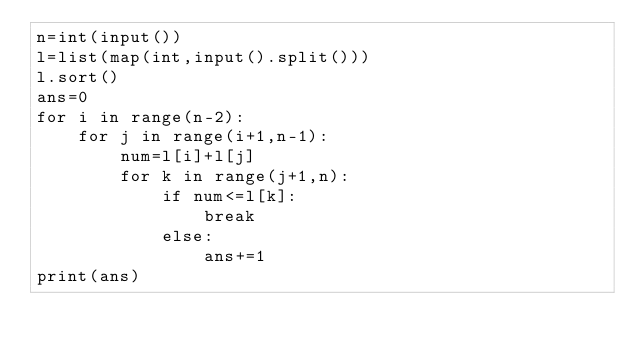Convert code to text. <code><loc_0><loc_0><loc_500><loc_500><_Python_>n=int(input())
l=list(map(int,input().split()))
l.sort()
ans=0
for i in range(n-2):
    for j in range(i+1,n-1):
        num=l[i]+l[j]
        for k in range(j+1,n):
            if num<=l[k]:
                break
            else:
                ans+=1
print(ans)
</code> 